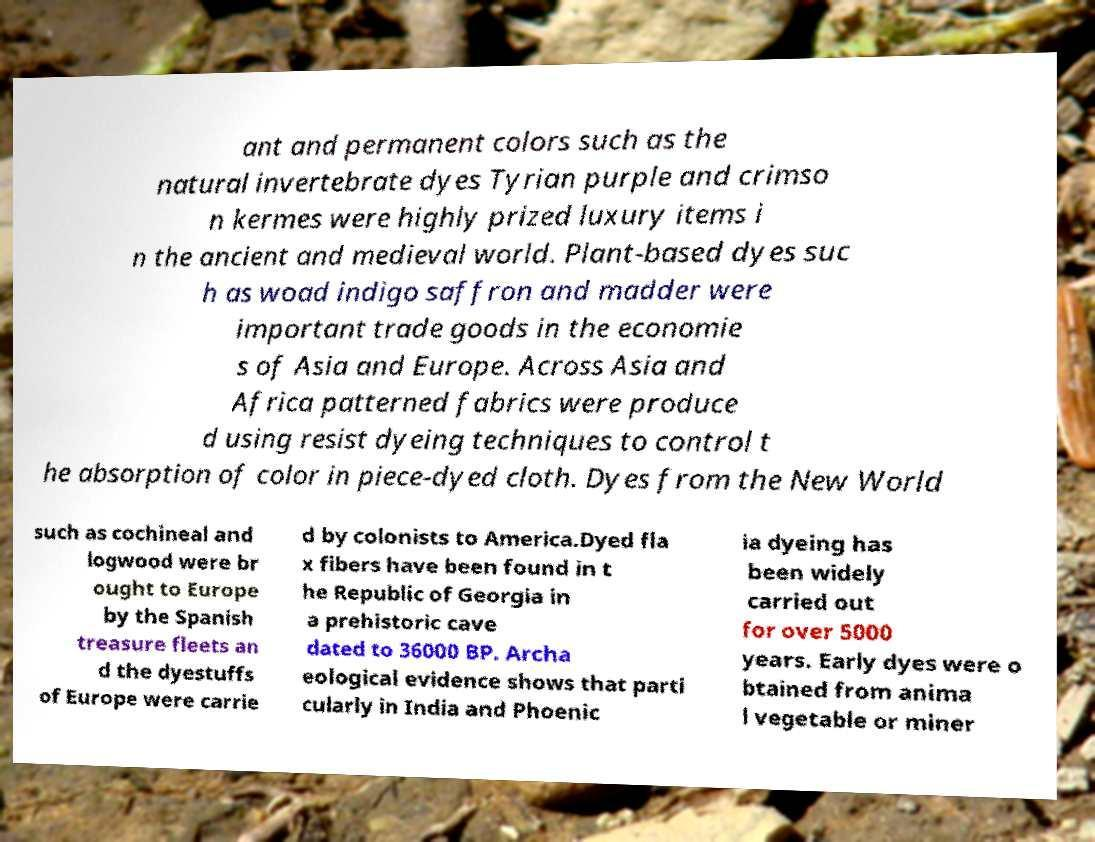Could you assist in decoding the text presented in this image and type it out clearly? ant and permanent colors such as the natural invertebrate dyes Tyrian purple and crimso n kermes were highly prized luxury items i n the ancient and medieval world. Plant-based dyes suc h as woad indigo saffron and madder were important trade goods in the economie s of Asia and Europe. Across Asia and Africa patterned fabrics were produce d using resist dyeing techniques to control t he absorption of color in piece-dyed cloth. Dyes from the New World such as cochineal and logwood were br ought to Europe by the Spanish treasure fleets an d the dyestuffs of Europe were carrie d by colonists to America.Dyed fla x fibers have been found in t he Republic of Georgia in a prehistoric cave dated to 36000 BP. Archa eological evidence shows that parti cularly in India and Phoenic ia dyeing has been widely carried out for over 5000 years. Early dyes were o btained from anima l vegetable or miner 